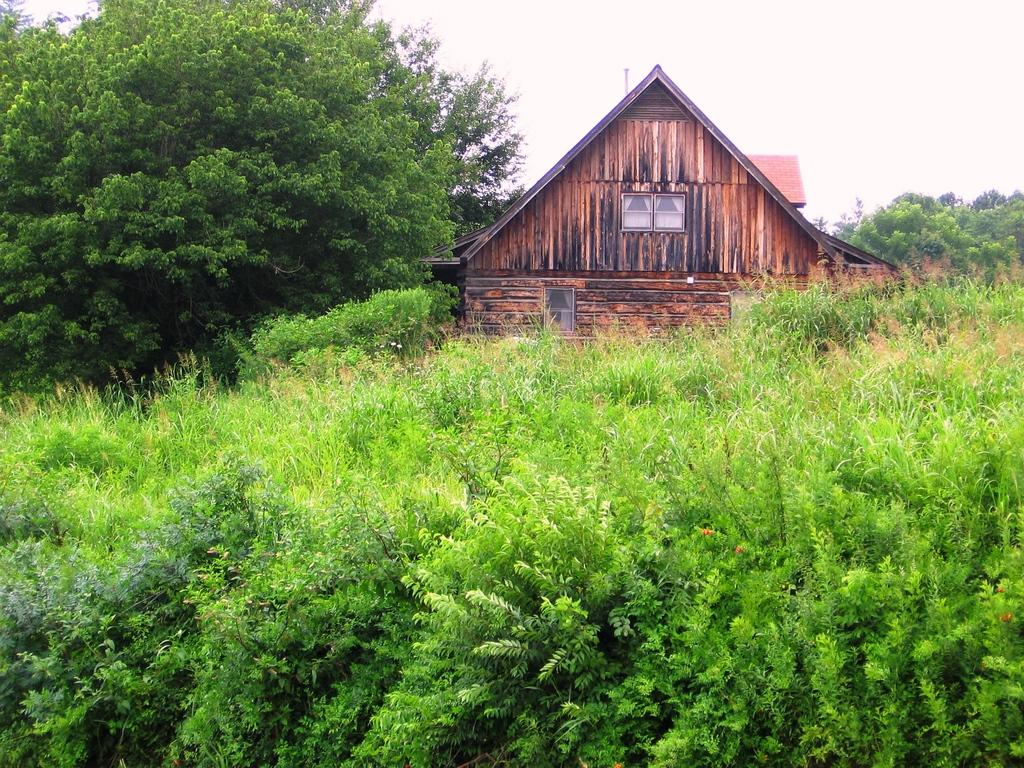What is located in the foreground of the picture? There are plants in the foreground of the picture. What can be seen in the center of the picture? There are trees and plants in the center, as well as a house. What is the condition of the sky in the picture? The sky is cloudy in the picture. What type of square can be seen in the center of the picture? There is no square present in the image; it features trees, plants, and a house in the center. What kind of toy is being used by the trees in the center of the picture? There are no toys present in the image; it features trees, plants, and a house in the center. 